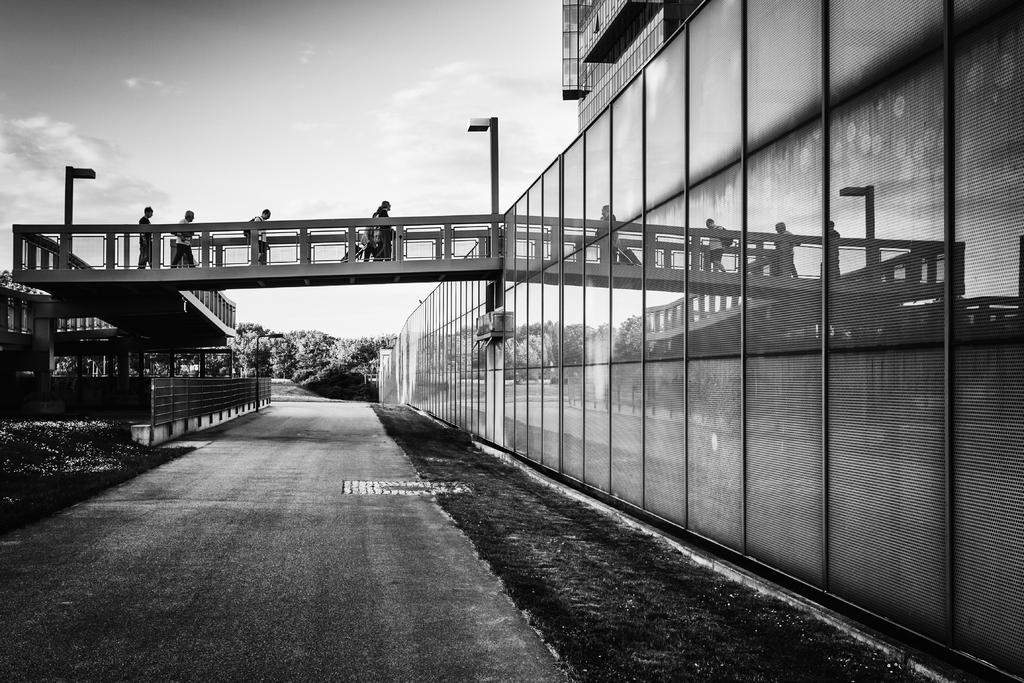In one or two sentences, can you explain what this image depicts? This is a black and white picture, we can see a few people walking on the bridge, there are some trees, poles, grass and wall, also we can see a building. 